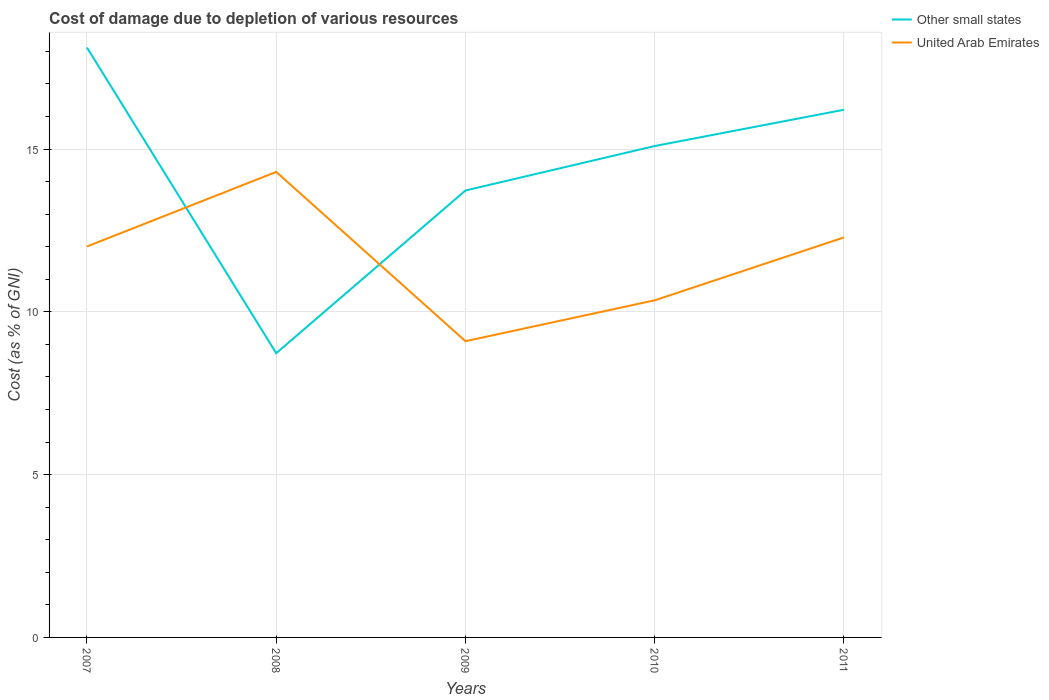How many different coloured lines are there?
Ensure brevity in your answer.  2. Is the number of lines equal to the number of legend labels?
Your answer should be compact. Yes. Across all years, what is the maximum cost of damage caused due to the depletion of various resources in United Arab Emirates?
Your answer should be compact. 9.1. What is the total cost of damage caused due to the depletion of various resources in United Arab Emirates in the graph?
Your answer should be very brief. -1.93. What is the difference between the highest and the second highest cost of damage caused due to the depletion of various resources in United Arab Emirates?
Keep it short and to the point. 5.2. What is the difference between the highest and the lowest cost of damage caused due to the depletion of various resources in Other small states?
Provide a succinct answer. 3. Is the cost of damage caused due to the depletion of various resources in Other small states strictly greater than the cost of damage caused due to the depletion of various resources in United Arab Emirates over the years?
Your answer should be very brief. No. Are the values on the major ticks of Y-axis written in scientific E-notation?
Your answer should be very brief. No. Does the graph contain any zero values?
Offer a very short reply. No. Where does the legend appear in the graph?
Give a very brief answer. Top right. How many legend labels are there?
Provide a short and direct response. 2. What is the title of the graph?
Offer a very short reply. Cost of damage due to depletion of various resources. Does "Faeroe Islands" appear as one of the legend labels in the graph?
Your response must be concise. No. What is the label or title of the Y-axis?
Your answer should be compact. Cost (as % of GNI). What is the Cost (as % of GNI) in Other small states in 2007?
Keep it short and to the point. 18.12. What is the Cost (as % of GNI) in United Arab Emirates in 2007?
Give a very brief answer. 12.01. What is the Cost (as % of GNI) of Other small states in 2008?
Provide a succinct answer. 8.73. What is the Cost (as % of GNI) of United Arab Emirates in 2008?
Make the answer very short. 14.3. What is the Cost (as % of GNI) of Other small states in 2009?
Offer a very short reply. 13.73. What is the Cost (as % of GNI) in United Arab Emirates in 2009?
Offer a very short reply. 9.1. What is the Cost (as % of GNI) in Other small states in 2010?
Your answer should be very brief. 15.09. What is the Cost (as % of GNI) in United Arab Emirates in 2010?
Your answer should be compact. 10.35. What is the Cost (as % of GNI) of Other small states in 2011?
Give a very brief answer. 16.21. What is the Cost (as % of GNI) of United Arab Emirates in 2011?
Your answer should be very brief. 12.28. Across all years, what is the maximum Cost (as % of GNI) of Other small states?
Keep it short and to the point. 18.12. Across all years, what is the maximum Cost (as % of GNI) in United Arab Emirates?
Your answer should be compact. 14.3. Across all years, what is the minimum Cost (as % of GNI) in Other small states?
Your answer should be compact. 8.73. Across all years, what is the minimum Cost (as % of GNI) of United Arab Emirates?
Your response must be concise. 9.1. What is the total Cost (as % of GNI) in Other small states in the graph?
Offer a terse response. 71.87. What is the total Cost (as % of GNI) in United Arab Emirates in the graph?
Make the answer very short. 58.04. What is the difference between the Cost (as % of GNI) of Other small states in 2007 and that in 2008?
Provide a short and direct response. 9.39. What is the difference between the Cost (as % of GNI) of United Arab Emirates in 2007 and that in 2008?
Your answer should be compact. -2.29. What is the difference between the Cost (as % of GNI) in Other small states in 2007 and that in 2009?
Offer a very short reply. 4.39. What is the difference between the Cost (as % of GNI) of United Arab Emirates in 2007 and that in 2009?
Provide a short and direct response. 2.91. What is the difference between the Cost (as % of GNI) in Other small states in 2007 and that in 2010?
Your response must be concise. 3.03. What is the difference between the Cost (as % of GNI) of United Arab Emirates in 2007 and that in 2010?
Give a very brief answer. 1.65. What is the difference between the Cost (as % of GNI) of Other small states in 2007 and that in 2011?
Provide a short and direct response. 1.91. What is the difference between the Cost (as % of GNI) of United Arab Emirates in 2007 and that in 2011?
Offer a terse response. -0.28. What is the difference between the Cost (as % of GNI) in Other small states in 2008 and that in 2009?
Provide a succinct answer. -5. What is the difference between the Cost (as % of GNI) in United Arab Emirates in 2008 and that in 2009?
Offer a very short reply. 5.2. What is the difference between the Cost (as % of GNI) of Other small states in 2008 and that in 2010?
Make the answer very short. -6.36. What is the difference between the Cost (as % of GNI) of United Arab Emirates in 2008 and that in 2010?
Your response must be concise. 3.94. What is the difference between the Cost (as % of GNI) of Other small states in 2008 and that in 2011?
Offer a very short reply. -7.48. What is the difference between the Cost (as % of GNI) of United Arab Emirates in 2008 and that in 2011?
Keep it short and to the point. 2.01. What is the difference between the Cost (as % of GNI) of Other small states in 2009 and that in 2010?
Make the answer very short. -1.37. What is the difference between the Cost (as % of GNI) in United Arab Emirates in 2009 and that in 2010?
Ensure brevity in your answer.  -1.26. What is the difference between the Cost (as % of GNI) in Other small states in 2009 and that in 2011?
Give a very brief answer. -2.48. What is the difference between the Cost (as % of GNI) of United Arab Emirates in 2009 and that in 2011?
Give a very brief answer. -3.19. What is the difference between the Cost (as % of GNI) of Other small states in 2010 and that in 2011?
Provide a short and direct response. -1.11. What is the difference between the Cost (as % of GNI) in United Arab Emirates in 2010 and that in 2011?
Give a very brief answer. -1.93. What is the difference between the Cost (as % of GNI) of Other small states in 2007 and the Cost (as % of GNI) of United Arab Emirates in 2008?
Offer a very short reply. 3.82. What is the difference between the Cost (as % of GNI) of Other small states in 2007 and the Cost (as % of GNI) of United Arab Emirates in 2009?
Offer a very short reply. 9.02. What is the difference between the Cost (as % of GNI) of Other small states in 2007 and the Cost (as % of GNI) of United Arab Emirates in 2010?
Your response must be concise. 7.76. What is the difference between the Cost (as % of GNI) of Other small states in 2007 and the Cost (as % of GNI) of United Arab Emirates in 2011?
Your answer should be very brief. 5.83. What is the difference between the Cost (as % of GNI) of Other small states in 2008 and the Cost (as % of GNI) of United Arab Emirates in 2009?
Your answer should be compact. -0.37. What is the difference between the Cost (as % of GNI) of Other small states in 2008 and the Cost (as % of GNI) of United Arab Emirates in 2010?
Offer a terse response. -1.62. What is the difference between the Cost (as % of GNI) in Other small states in 2008 and the Cost (as % of GNI) in United Arab Emirates in 2011?
Give a very brief answer. -3.56. What is the difference between the Cost (as % of GNI) of Other small states in 2009 and the Cost (as % of GNI) of United Arab Emirates in 2010?
Give a very brief answer. 3.37. What is the difference between the Cost (as % of GNI) in Other small states in 2009 and the Cost (as % of GNI) in United Arab Emirates in 2011?
Provide a short and direct response. 1.44. What is the difference between the Cost (as % of GNI) of Other small states in 2010 and the Cost (as % of GNI) of United Arab Emirates in 2011?
Keep it short and to the point. 2.81. What is the average Cost (as % of GNI) of Other small states per year?
Give a very brief answer. 14.37. What is the average Cost (as % of GNI) in United Arab Emirates per year?
Offer a very short reply. 11.61. In the year 2007, what is the difference between the Cost (as % of GNI) in Other small states and Cost (as % of GNI) in United Arab Emirates?
Make the answer very short. 6.11. In the year 2008, what is the difference between the Cost (as % of GNI) in Other small states and Cost (as % of GNI) in United Arab Emirates?
Your answer should be very brief. -5.57. In the year 2009, what is the difference between the Cost (as % of GNI) of Other small states and Cost (as % of GNI) of United Arab Emirates?
Your answer should be very brief. 4.63. In the year 2010, what is the difference between the Cost (as % of GNI) of Other small states and Cost (as % of GNI) of United Arab Emirates?
Your answer should be very brief. 4.74. In the year 2011, what is the difference between the Cost (as % of GNI) of Other small states and Cost (as % of GNI) of United Arab Emirates?
Offer a very short reply. 3.92. What is the ratio of the Cost (as % of GNI) of Other small states in 2007 to that in 2008?
Keep it short and to the point. 2.08. What is the ratio of the Cost (as % of GNI) of United Arab Emirates in 2007 to that in 2008?
Provide a succinct answer. 0.84. What is the ratio of the Cost (as % of GNI) of Other small states in 2007 to that in 2009?
Keep it short and to the point. 1.32. What is the ratio of the Cost (as % of GNI) of United Arab Emirates in 2007 to that in 2009?
Offer a very short reply. 1.32. What is the ratio of the Cost (as % of GNI) in Other small states in 2007 to that in 2010?
Give a very brief answer. 1.2. What is the ratio of the Cost (as % of GNI) in United Arab Emirates in 2007 to that in 2010?
Give a very brief answer. 1.16. What is the ratio of the Cost (as % of GNI) in Other small states in 2007 to that in 2011?
Your answer should be very brief. 1.12. What is the ratio of the Cost (as % of GNI) in United Arab Emirates in 2007 to that in 2011?
Offer a very short reply. 0.98. What is the ratio of the Cost (as % of GNI) in Other small states in 2008 to that in 2009?
Provide a short and direct response. 0.64. What is the ratio of the Cost (as % of GNI) of United Arab Emirates in 2008 to that in 2009?
Provide a short and direct response. 1.57. What is the ratio of the Cost (as % of GNI) in Other small states in 2008 to that in 2010?
Ensure brevity in your answer.  0.58. What is the ratio of the Cost (as % of GNI) in United Arab Emirates in 2008 to that in 2010?
Your answer should be very brief. 1.38. What is the ratio of the Cost (as % of GNI) in Other small states in 2008 to that in 2011?
Keep it short and to the point. 0.54. What is the ratio of the Cost (as % of GNI) of United Arab Emirates in 2008 to that in 2011?
Offer a very short reply. 1.16. What is the ratio of the Cost (as % of GNI) in Other small states in 2009 to that in 2010?
Keep it short and to the point. 0.91. What is the ratio of the Cost (as % of GNI) of United Arab Emirates in 2009 to that in 2010?
Ensure brevity in your answer.  0.88. What is the ratio of the Cost (as % of GNI) of Other small states in 2009 to that in 2011?
Make the answer very short. 0.85. What is the ratio of the Cost (as % of GNI) in United Arab Emirates in 2009 to that in 2011?
Offer a terse response. 0.74. What is the ratio of the Cost (as % of GNI) of Other small states in 2010 to that in 2011?
Provide a succinct answer. 0.93. What is the ratio of the Cost (as % of GNI) in United Arab Emirates in 2010 to that in 2011?
Your answer should be very brief. 0.84. What is the difference between the highest and the second highest Cost (as % of GNI) of Other small states?
Give a very brief answer. 1.91. What is the difference between the highest and the second highest Cost (as % of GNI) in United Arab Emirates?
Ensure brevity in your answer.  2.01. What is the difference between the highest and the lowest Cost (as % of GNI) in Other small states?
Offer a very short reply. 9.39. What is the difference between the highest and the lowest Cost (as % of GNI) of United Arab Emirates?
Ensure brevity in your answer.  5.2. 